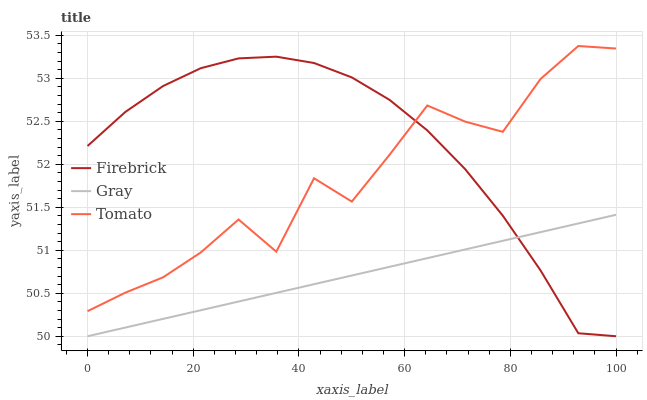Does Gray have the minimum area under the curve?
Answer yes or no. Yes. Does Firebrick have the maximum area under the curve?
Answer yes or no. Yes. Does Firebrick have the minimum area under the curve?
Answer yes or no. No. Does Gray have the maximum area under the curve?
Answer yes or no. No. Is Gray the smoothest?
Answer yes or no. Yes. Is Tomato the roughest?
Answer yes or no. Yes. Is Firebrick the smoothest?
Answer yes or no. No. Is Firebrick the roughest?
Answer yes or no. No. Does Gray have the lowest value?
Answer yes or no. Yes. Does Tomato have the highest value?
Answer yes or no. Yes. Does Firebrick have the highest value?
Answer yes or no. No. Is Gray less than Tomato?
Answer yes or no. Yes. Is Tomato greater than Gray?
Answer yes or no. Yes. Does Gray intersect Firebrick?
Answer yes or no. Yes. Is Gray less than Firebrick?
Answer yes or no. No. Is Gray greater than Firebrick?
Answer yes or no. No. Does Gray intersect Tomato?
Answer yes or no. No. 